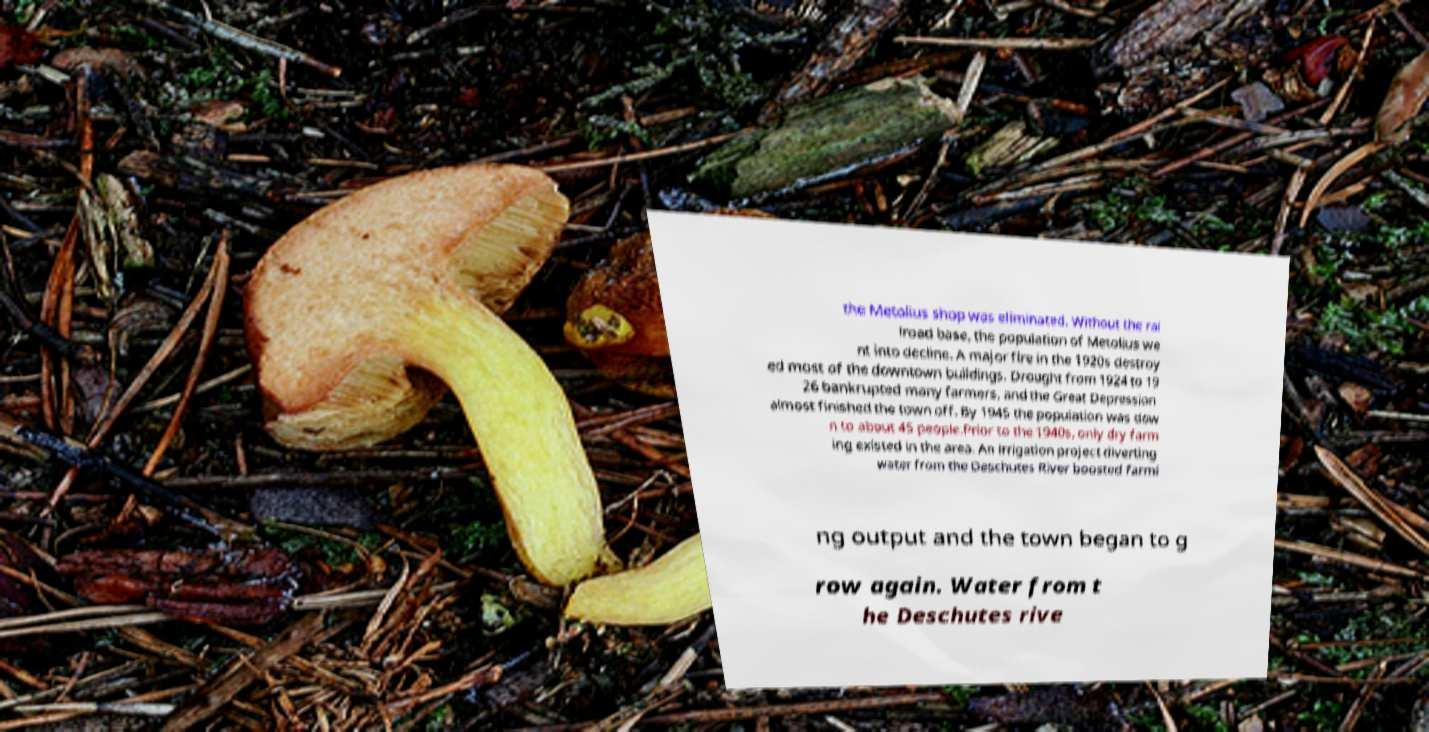Could you assist in decoding the text presented in this image and type it out clearly? the Metolius shop was eliminated. Without the rai lroad base, the population of Metolius we nt into decline. A major fire in the 1920s destroy ed most of the downtown buildings. Drought from 1924 to 19 26 bankrupted many farmers, and the Great Depression almost finished the town off. By 1945 the population was dow n to about 45 people.Prior to the 1940s, only dry farm ing existed in the area. An irrigation project diverting water from the Deschutes River boosted farmi ng output and the town began to g row again. Water from t he Deschutes rive 